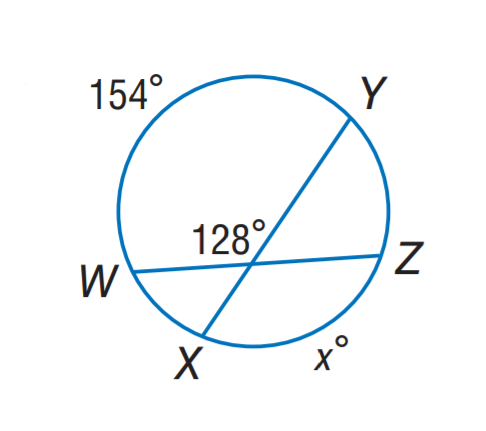Question: Find x.
Choices:
A. 92
B. 102
C. 128
D. 154
Answer with the letter. Answer: B 